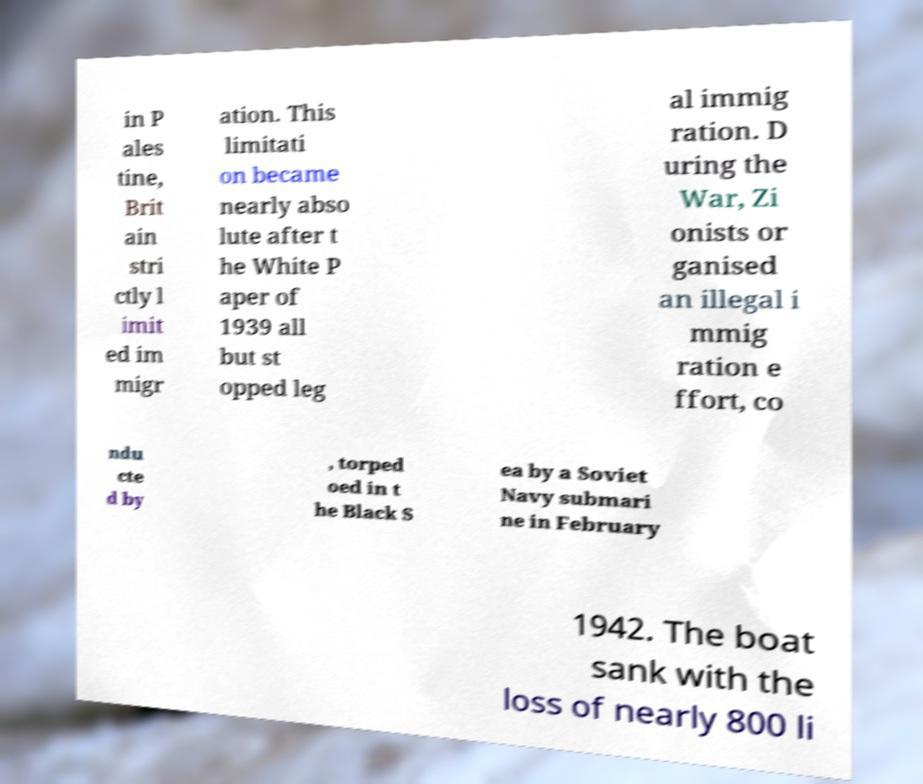Could you assist in decoding the text presented in this image and type it out clearly? in P ales tine, Brit ain stri ctly l imit ed im migr ation. This limitati on became nearly abso lute after t he White P aper of 1939 all but st opped leg al immig ration. D uring the War, Zi onists or ganised an illegal i mmig ration e ffort, co ndu cte d by , torped oed in t he Black S ea by a Soviet Navy submari ne in February 1942. The boat sank with the loss of nearly 800 li 